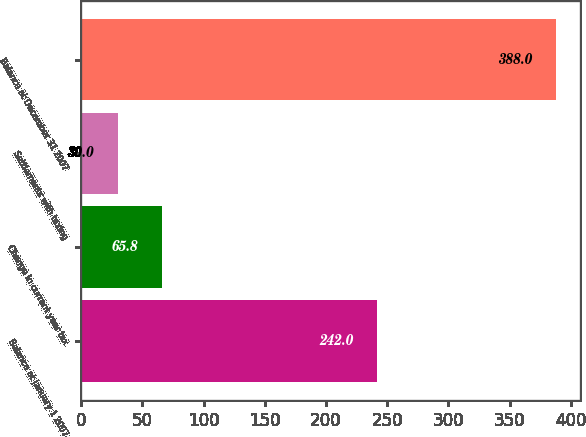Convert chart. <chart><loc_0><loc_0><loc_500><loc_500><bar_chart><fcel>Balance at January 1 2007<fcel>Change in current year tax<fcel>Settlements with taxing<fcel>Balance at December 31 2007<nl><fcel>242<fcel>65.8<fcel>30<fcel>388<nl></chart> 